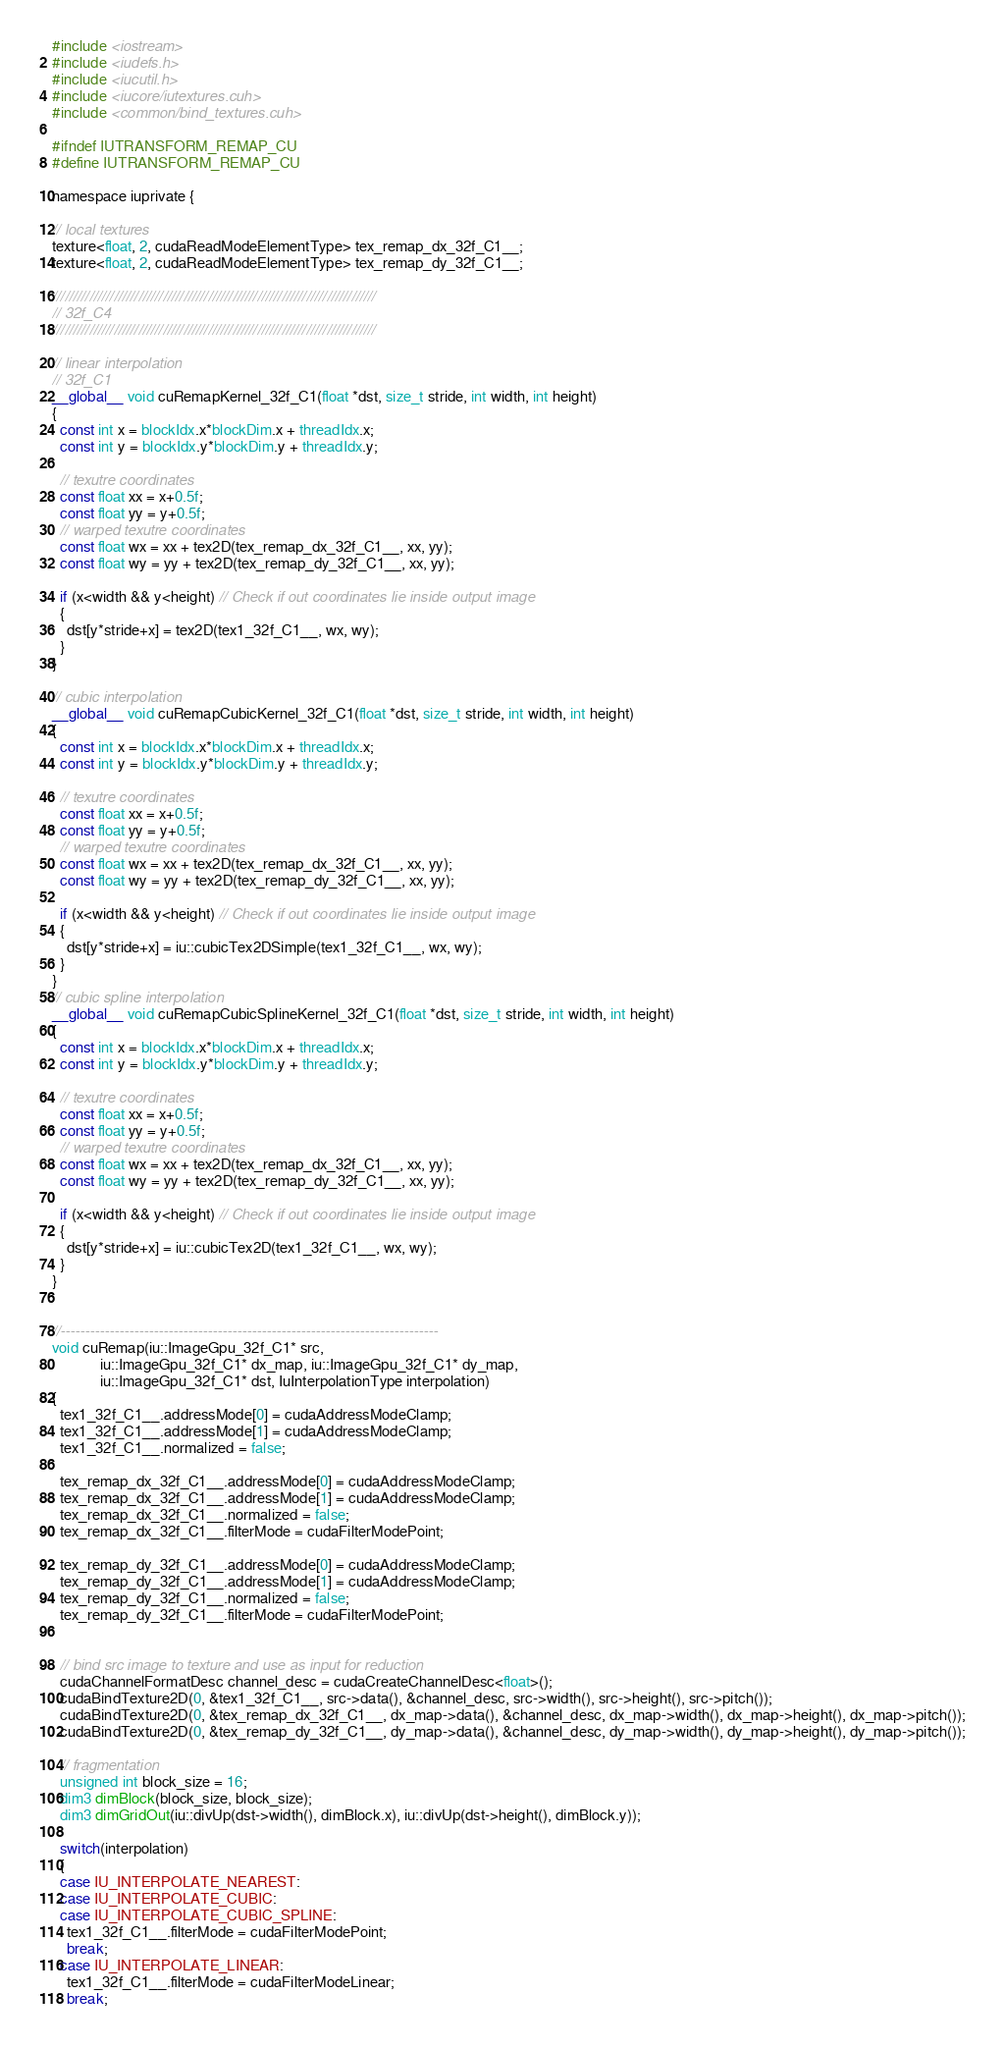Convert code to text. <code><loc_0><loc_0><loc_500><loc_500><_Cuda_>#include <iostream>
#include <iudefs.h>
#include <iucutil.h>
#include <iucore/iutextures.cuh>
#include <common/bind_textures.cuh>

#ifndef IUTRANSFORM_REMAP_CU
#define IUTRANSFORM_REMAP_CU

namespace iuprivate {

// local textures
texture<float, 2, cudaReadModeElementType> tex_remap_dx_32f_C1__;
texture<float, 2, cudaReadModeElementType> tex_remap_dy_32f_C1__;

///////////////////////////////////////////////////////////////////////////////
// 32f_C4
///////////////////////////////////////////////////////////////////////////////

// linear interpolation
// 32f_C1
__global__ void cuRemapKernel_32f_C1(float *dst, size_t stride, int width, int height)
{
  const int x = blockIdx.x*blockDim.x + threadIdx.x;
  const int y = blockIdx.y*blockDim.y + threadIdx.y;

  // texutre coordinates
  const float xx = x+0.5f;
  const float yy = y+0.5f;
  // warped texutre coordinates
  const float wx = xx + tex2D(tex_remap_dx_32f_C1__, xx, yy);
  const float wy = yy + tex2D(tex_remap_dy_32f_C1__, xx, yy);

  if (x<width && y<height) // Check if out coordinates lie inside output image
  {
    dst[y*stride+x] = tex2D(tex1_32f_C1__, wx, wy);
  }
}

// cubic interpolation
__global__ void cuRemapCubicKernel_32f_C1(float *dst, size_t stride, int width, int height)
{
  const int x = blockIdx.x*blockDim.x + threadIdx.x;
  const int y = blockIdx.y*blockDim.y + threadIdx.y;

  // texutre coordinates
  const float xx = x+0.5f;
  const float yy = y+0.5f;
  // warped texutre coordinates
  const float wx = xx + tex2D(tex_remap_dx_32f_C1__, xx, yy);
  const float wy = yy + tex2D(tex_remap_dy_32f_C1__, xx, yy);

  if (x<width && y<height) // Check if out coordinates lie inside output image
  {
    dst[y*stride+x] = iu::cubicTex2DSimple(tex1_32f_C1__, wx, wy);
  }
}
// cubic spline interpolation
__global__ void cuRemapCubicSplineKernel_32f_C1(float *dst, size_t stride, int width, int height)
{
  const int x = blockIdx.x*blockDim.x + threadIdx.x;
  const int y = blockIdx.y*blockDim.y + threadIdx.y;

  // texutre coordinates
  const float xx = x+0.5f;
  const float yy = y+0.5f;
  // warped texutre coordinates
  const float wx = xx + tex2D(tex_remap_dx_32f_C1__, xx, yy);
  const float wy = yy + tex2D(tex_remap_dy_32f_C1__, xx, yy);

  if (x<width && y<height) // Check if out coordinates lie inside output image
  {
    dst[y*stride+x] = iu::cubicTex2D(tex1_32f_C1__, wx, wy);
  }
}


//-----------------------------------------------------------------------------
void cuRemap(iu::ImageGpu_32f_C1* src,
             iu::ImageGpu_32f_C1* dx_map, iu::ImageGpu_32f_C1* dy_map,
             iu::ImageGpu_32f_C1* dst, IuInterpolationType interpolation)
{
  tex1_32f_C1__.addressMode[0] = cudaAddressModeClamp;
  tex1_32f_C1__.addressMode[1] = cudaAddressModeClamp;
  tex1_32f_C1__.normalized = false;

  tex_remap_dx_32f_C1__.addressMode[0] = cudaAddressModeClamp;
  tex_remap_dx_32f_C1__.addressMode[1] = cudaAddressModeClamp;
  tex_remap_dx_32f_C1__.normalized = false;
  tex_remap_dx_32f_C1__.filterMode = cudaFilterModePoint;

  tex_remap_dy_32f_C1__.addressMode[0] = cudaAddressModeClamp;
  tex_remap_dy_32f_C1__.addressMode[1] = cudaAddressModeClamp;
  tex_remap_dy_32f_C1__.normalized = false;
  tex_remap_dy_32f_C1__.filterMode = cudaFilterModePoint;


  // bind src image to texture and use as input for reduction
  cudaChannelFormatDesc channel_desc = cudaCreateChannelDesc<float>();
  cudaBindTexture2D(0, &tex1_32f_C1__, src->data(), &channel_desc, src->width(), src->height(), src->pitch());
  cudaBindTexture2D(0, &tex_remap_dx_32f_C1__, dx_map->data(), &channel_desc, dx_map->width(), dx_map->height(), dx_map->pitch());
  cudaBindTexture2D(0, &tex_remap_dy_32f_C1__, dy_map->data(), &channel_desc, dy_map->width(), dy_map->height(), dy_map->pitch());

  // fragmentation
  unsigned int block_size = 16;
  dim3 dimBlock(block_size, block_size);
  dim3 dimGridOut(iu::divUp(dst->width(), dimBlock.x), iu::divUp(dst->height(), dimBlock.y));

  switch(interpolation)
  {
  case IU_INTERPOLATE_NEAREST:
  case IU_INTERPOLATE_CUBIC:
  case IU_INTERPOLATE_CUBIC_SPLINE:
    tex1_32f_C1__.filterMode = cudaFilterModePoint;
    break;
  case IU_INTERPOLATE_LINEAR:
    tex1_32f_C1__.filterMode = cudaFilterModeLinear;
    break;</code> 